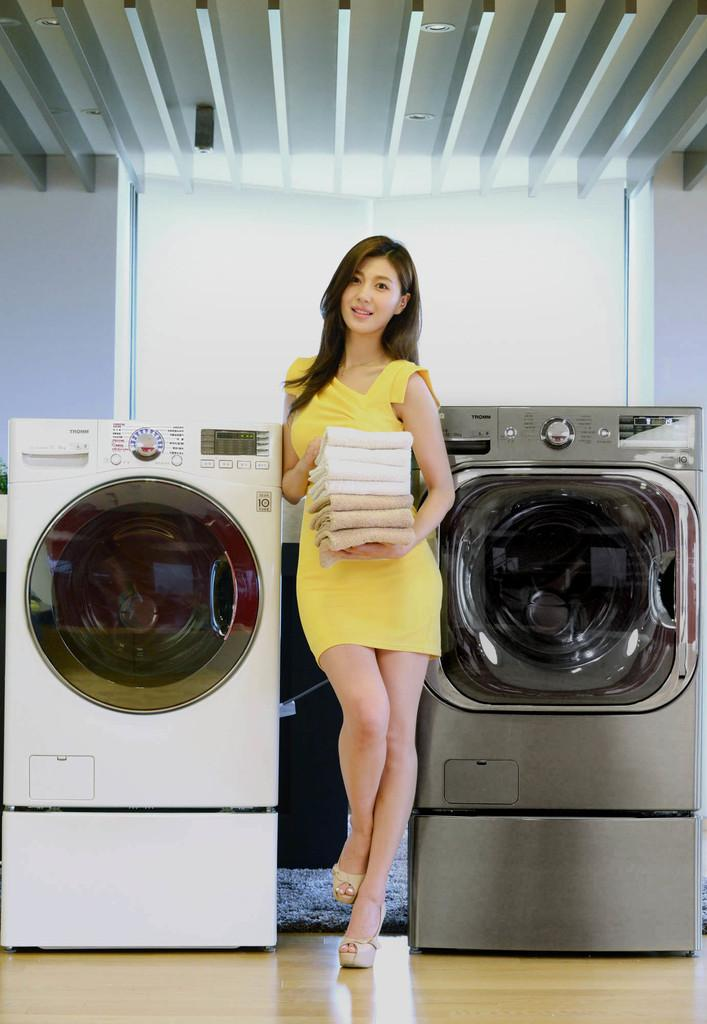Who is present in the image? There is a woman in the image. What is the woman wearing? The woman is wearing a yellow dress. What is the woman holding in the image? The woman is holding clothes. What type of appliances can be seen in the image? There are washing machines in the image. What is the floor covering in the image? The floor has a carpet. What type of lace can be seen on the queen's dress in the image? There is no queen or lace present in the image; it features a woman holding clothes and washing machines. 